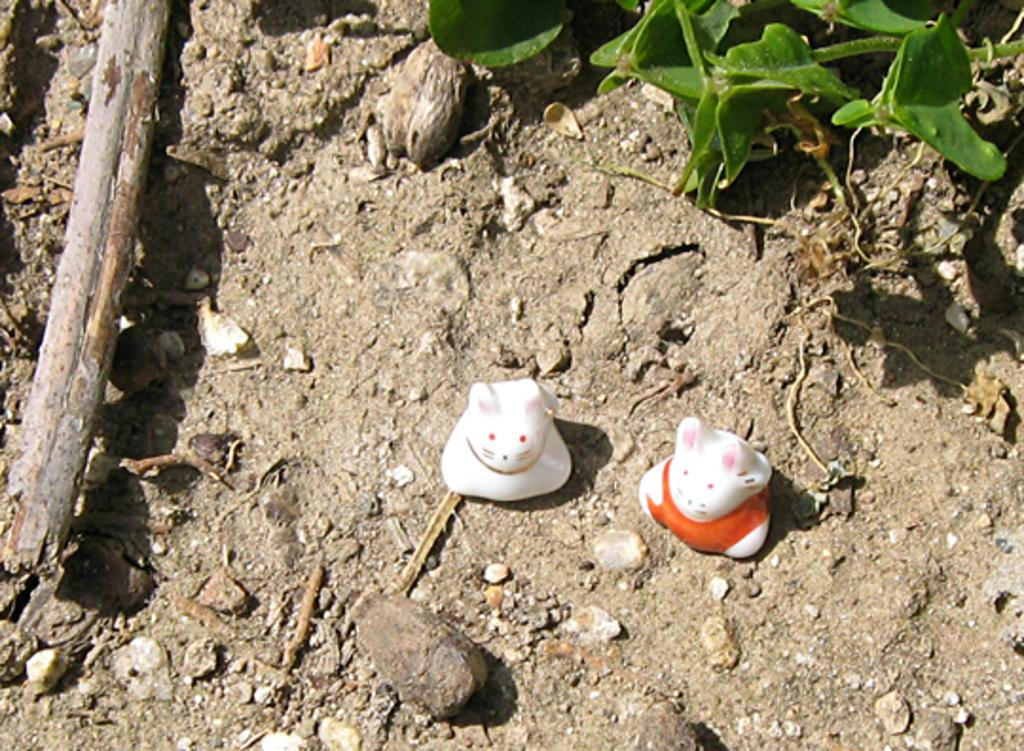How many toys can be seen in the image? There are two toys in the image. What other objects are present in the image besides the toys? There is a plant, stones, a stick, and mud in the image. Can you describe the plant in the image? The plant is not described in the provided facts, so we cannot provide any details about it. What type of material is the stick made of? The material of the stick is not specified in the provided facts. How does the pan turn in the image? There is no pan present in the image, so it cannot be turned. 